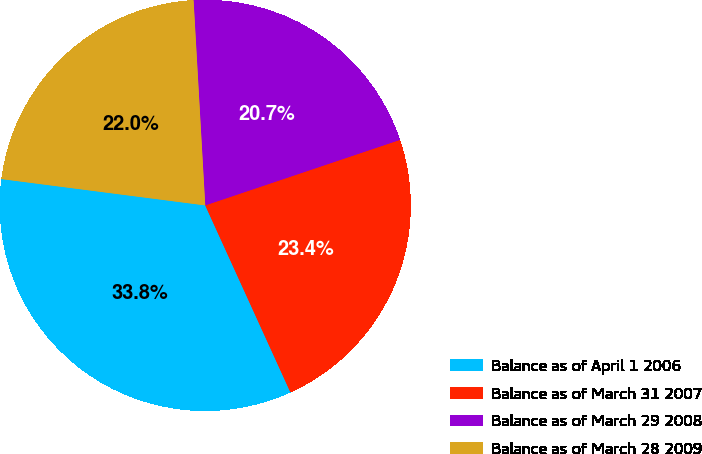Convert chart. <chart><loc_0><loc_0><loc_500><loc_500><pie_chart><fcel>Balance as of April 1 2006<fcel>Balance as of March 31 2007<fcel>Balance as of March 29 2008<fcel>Balance as of March 28 2009<nl><fcel>33.85%<fcel>23.36%<fcel>20.74%<fcel>22.05%<nl></chart> 